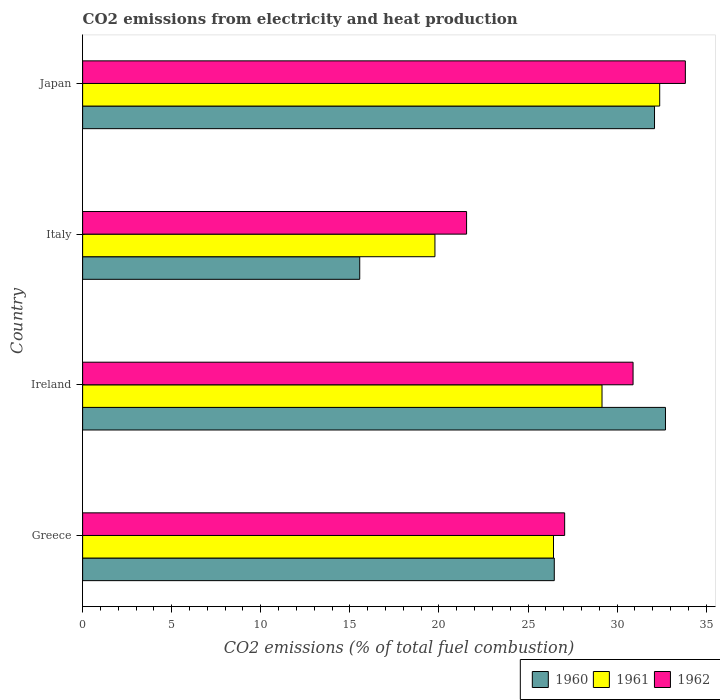How many different coloured bars are there?
Provide a succinct answer. 3. Are the number of bars per tick equal to the number of legend labels?
Ensure brevity in your answer.  Yes. Are the number of bars on each tick of the Y-axis equal?
Your answer should be very brief. Yes. What is the label of the 3rd group of bars from the top?
Offer a very short reply. Ireland. In how many cases, is the number of bars for a given country not equal to the number of legend labels?
Make the answer very short. 0. What is the amount of CO2 emitted in 1961 in Ireland?
Offer a terse response. 29.15. Across all countries, what is the maximum amount of CO2 emitted in 1961?
Ensure brevity in your answer.  32.39. Across all countries, what is the minimum amount of CO2 emitted in 1962?
Make the answer very short. 21.55. In which country was the amount of CO2 emitted in 1962 maximum?
Provide a succinct answer. Japan. In which country was the amount of CO2 emitted in 1960 minimum?
Provide a succinct answer. Italy. What is the total amount of CO2 emitted in 1962 in the graph?
Your response must be concise. 113.34. What is the difference between the amount of CO2 emitted in 1960 in Greece and that in Japan?
Offer a terse response. -5.63. What is the difference between the amount of CO2 emitted in 1961 in Italy and the amount of CO2 emitted in 1960 in Japan?
Ensure brevity in your answer.  -12.33. What is the average amount of CO2 emitted in 1960 per country?
Your answer should be very brief. 26.71. What is the difference between the amount of CO2 emitted in 1962 and amount of CO2 emitted in 1961 in Ireland?
Your response must be concise. 1.74. In how many countries, is the amount of CO2 emitted in 1962 greater than 24 %?
Make the answer very short. 3. What is the ratio of the amount of CO2 emitted in 1962 in Italy to that in Japan?
Your response must be concise. 0.64. Is the amount of CO2 emitted in 1960 in Greece less than that in Italy?
Your response must be concise. No. Is the difference between the amount of CO2 emitted in 1962 in Ireland and Japan greater than the difference between the amount of CO2 emitted in 1961 in Ireland and Japan?
Your response must be concise. Yes. What is the difference between the highest and the second highest amount of CO2 emitted in 1962?
Your answer should be very brief. 2.94. What is the difference between the highest and the lowest amount of CO2 emitted in 1962?
Your answer should be compact. 12.28. Is the sum of the amount of CO2 emitted in 1961 in Greece and Japan greater than the maximum amount of CO2 emitted in 1960 across all countries?
Give a very brief answer. Yes. What does the 1st bar from the top in Italy represents?
Provide a succinct answer. 1962. What does the 1st bar from the bottom in Japan represents?
Ensure brevity in your answer.  1960. Is it the case that in every country, the sum of the amount of CO2 emitted in 1962 and amount of CO2 emitted in 1960 is greater than the amount of CO2 emitted in 1961?
Give a very brief answer. Yes. How many bars are there?
Make the answer very short. 12. Are the values on the major ticks of X-axis written in scientific E-notation?
Provide a succinct answer. No. How many legend labels are there?
Your response must be concise. 3. What is the title of the graph?
Provide a short and direct response. CO2 emissions from electricity and heat production. Does "1964" appear as one of the legend labels in the graph?
Offer a terse response. No. What is the label or title of the X-axis?
Provide a succinct answer. CO2 emissions (% of total fuel combustion). What is the CO2 emissions (% of total fuel combustion) in 1960 in Greece?
Your answer should be very brief. 26.47. What is the CO2 emissions (% of total fuel combustion) in 1961 in Greece?
Your response must be concise. 26.43. What is the CO2 emissions (% of total fuel combustion) in 1962 in Greece?
Make the answer very short. 27.06. What is the CO2 emissions (% of total fuel combustion) of 1960 in Ireland?
Ensure brevity in your answer.  32.72. What is the CO2 emissions (% of total fuel combustion) in 1961 in Ireland?
Keep it short and to the point. 29.15. What is the CO2 emissions (% of total fuel combustion) of 1962 in Ireland?
Your answer should be very brief. 30.9. What is the CO2 emissions (% of total fuel combustion) of 1960 in Italy?
Ensure brevity in your answer.  15.55. What is the CO2 emissions (% of total fuel combustion) in 1961 in Italy?
Your answer should be very brief. 19.78. What is the CO2 emissions (% of total fuel combustion) in 1962 in Italy?
Make the answer very short. 21.55. What is the CO2 emissions (% of total fuel combustion) in 1960 in Japan?
Make the answer very short. 32.1. What is the CO2 emissions (% of total fuel combustion) in 1961 in Japan?
Provide a succinct answer. 32.39. What is the CO2 emissions (% of total fuel combustion) of 1962 in Japan?
Your answer should be compact. 33.83. Across all countries, what is the maximum CO2 emissions (% of total fuel combustion) in 1960?
Provide a succinct answer. 32.72. Across all countries, what is the maximum CO2 emissions (% of total fuel combustion) in 1961?
Provide a short and direct response. 32.39. Across all countries, what is the maximum CO2 emissions (% of total fuel combustion) of 1962?
Offer a very short reply. 33.83. Across all countries, what is the minimum CO2 emissions (% of total fuel combustion) in 1960?
Your response must be concise. 15.55. Across all countries, what is the minimum CO2 emissions (% of total fuel combustion) in 1961?
Give a very brief answer. 19.78. Across all countries, what is the minimum CO2 emissions (% of total fuel combustion) of 1962?
Keep it short and to the point. 21.55. What is the total CO2 emissions (% of total fuel combustion) in 1960 in the graph?
Provide a short and direct response. 106.85. What is the total CO2 emissions (% of total fuel combustion) of 1961 in the graph?
Your answer should be very brief. 107.75. What is the total CO2 emissions (% of total fuel combustion) in 1962 in the graph?
Provide a short and direct response. 113.34. What is the difference between the CO2 emissions (% of total fuel combustion) of 1960 in Greece and that in Ireland?
Ensure brevity in your answer.  -6.24. What is the difference between the CO2 emissions (% of total fuel combustion) of 1961 in Greece and that in Ireland?
Your answer should be very brief. -2.72. What is the difference between the CO2 emissions (% of total fuel combustion) of 1962 in Greece and that in Ireland?
Offer a terse response. -3.84. What is the difference between the CO2 emissions (% of total fuel combustion) in 1960 in Greece and that in Italy?
Give a very brief answer. 10.92. What is the difference between the CO2 emissions (% of total fuel combustion) in 1961 in Greece and that in Italy?
Your response must be concise. 6.66. What is the difference between the CO2 emissions (% of total fuel combustion) of 1962 in Greece and that in Italy?
Provide a succinct answer. 5.51. What is the difference between the CO2 emissions (% of total fuel combustion) of 1960 in Greece and that in Japan?
Give a very brief answer. -5.63. What is the difference between the CO2 emissions (% of total fuel combustion) in 1961 in Greece and that in Japan?
Your answer should be very brief. -5.96. What is the difference between the CO2 emissions (% of total fuel combustion) in 1962 in Greece and that in Japan?
Offer a very short reply. -6.78. What is the difference between the CO2 emissions (% of total fuel combustion) in 1960 in Ireland and that in Italy?
Offer a terse response. 17.16. What is the difference between the CO2 emissions (% of total fuel combustion) of 1961 in Ireland and that in Italy?
Ensure brevity in your answer.  9.38. What is the difference between the CO2 emissions (% of total fuel combustion) of 1962 in Ireland and that in Italy?
Ensure brevity in your answer.  9.35. What is the difference between the CO2 emissions (% of total fuel combustion) of 1960 in Ireland and that in Japan?
Offer a terse response. 0.61. What is the difference between the CO2 emissions (% of total fuel combustion) in 1961 in Ireland and that in Japan?
Offer a very short reply. -3.24. What is the difference between the CO2 emissions (% of total fuel combustion) of 1962 in Ireland and that in Japan?
Offer a very short reply. -2.94. What is the difference between the CO2 emissions (% of total fuel combustion) in 1960 in Italy and that in Japan?
Provide a succinct answer. -16.55. What is the difference between the CO2 emissions (% of total fuel combustion) of 1961 in Italy and that in Japan?
Keep it short and to the point. -12.62. What is the difference between the CO2 emissions (% of total fuel combustion) in 1962 in Italy and that in Japan?
Provide a short and direct response. -12.28. What is the difference between the CO2 emissions (% of total fuel combustion) in 1960 in Greece and the CO2 emissions (% of total fuel combustion) in 1961 in Ireland?
Offer a very short reply. -2.68. What is the difference between the CO2 emissions (% of total fuel combustion) of 1960 in Greece and the CO2 emissions (% of total fuel combustion) of 1962 in Ireland?
Your response must be concise. -4.42. What is the difference between the CO2 emissions (% of total fuel combustion) in 1961 in Greece and the CO2 emissions (% of total fuel combustion) in 1962 in Ireland?
Your answer should be compact. -4.47. What is the difference between the CO2 emissions (% of total fuel combustion) in 1960 in Greece and the CO2 emissions (% of total fuel combustion) in 1961 in Italy?
Provide a short and direct response. 6.7. What is the difference between the CO2 emissions (% of total fuel combustion) in 1960 in Greece and the CO2 emissions (% of total fuel combustion) in 1962 in Italy?
Your answer should be very brief. 4.92. What is the difference between the CO2 emissions (% of total fuel combustion) of 1961 in Greece and the CO2 emissions (% of total fuel combustion) of 1962 in Italy?
Keep it short and to the point. 4.88. What is the difference between the CO2 emissions (% of total fuel combustion) of 1960 in Greece and the CO2 emissions (% of total fuel combustion) of 1961 in Japan?
Give a very brief answer. -5.92. What is the difference between the CO2 emissions (% of total fuel combustion) in 1960 in Greece and the CO2 emissions (% of total fuel combustion) in 1962 in Japan?
Provide a succinct answer. -7.36. What is the difference between the CO2 emissions (% of total fuel combustion) in 1961 in Greece and the CO2 emissions (% of total fuel combustion) in 1962 in Japan?
Provide a succinct answer. -7.4. What is the difference between the CO2 emissions (% of total fuel combustion) in 1960 in Ireland and the CO2 emissions (% of total fuel combustion) in 1961 in Italy?
Provide a short and direct response. 12.94. What is the difference between the CO2 emissions (% of total fuel combustion) in 1960 in Ireland and the CO2 emissions (% of total fuel combustion) in 1962 in Italy?
Offer a very short reply. 11.16. What is the difference between the CO2 emissions (% of total fuel combustion) of 1961 in Ireland and the CO2 emissions (% of total fuel combustion) of 1962 in Italy?
Offer a very short reply. 7.6. What is the difference between the CO2 emissions (% of total fuel combustion) of 1960 in Ireland and the CO2 emissions (% of total fuel combustion) of 1961 in Japan?
Ensure brevity in your answer.  0.32. What is the difference between the CO2 emissions (% of total fuel combustion) of 1960 in Ireland and the CO2 emissions (% of total fuel combustion) of 1962 in Japan?
Your response must be concise. -1.12. What is the difference between the CO2 emissions (% of total fuel combustion) of 1961 in Ireland and the CO2 emissions (% of total fuel combustion) of 1962 in Japan?
Your answer should be compact. -4.68. What is the difference between the CO2 emissions (% of total fuel combustion) in 1960 in Italy and the CO2 emissions (% of total fuel combustion) in 1961 in Japan?
Offer a very short reply. -16.84. What is the difference between the CO2 emissions (% of total fuel combustion) of 1960 in Italy and the CO2 emissions (% of total fuel combustion) of 1962 in Japan?
Your response must be concise. -18.28. What is the difference between the CO2 emissions (% of total fuel combustion) of 1961 in Italy and the CO2 emissions (% of total fuel combustion) of 1962 in Japan?
Give a very brief answer. -14.06. What is the average CO2 emissions (% of total fuel combustion) of 1960 per country?
Keep it short and to the point. 26.71. What is the average CO2 emissions (% of total fuel combustion) of 1961 per country?
Your answer should be compact. 26.94. What is the average CO2 emissions (% of total fuel combustion) of 1962 per country?
Ensure brevity in your answer.  28.33. What is the difference between the CO2 emissions (% of total fuel combustion) in 1960 and CO2 emissions (% of total fuel combustion) in 1961 in Greece?
Offer a terse response. 0.04. What is the difference between the CO2 emissions (% of total fuel combustion) in 1960 and CO2 emissions (% of total fuel combustion) in 1962 in Greece?
Keep it short and to the point. -0.58. What is the difference between the CO2 emissions (% of total fuel combustion) in 1961 and CO2 emissions (% of total fuel combustion) in 1962 in Greece?
Offer a very short reply. -0.63. What is the difference between the CO2 emissions (% of total fuel combustion) in 1960 and CO2 emissions (% of total fuel combustion) in 1961 in Ireland?
Provide a short and direct response. 3.56. What is the difference between the CO2 emissions (% of total fuel combustion) in 1960 and CO2 emissions (% of total fuel combustion) in 1962 in Ireland?
Keep it short and to the point. 1.82. What is the difference between the CO2 emissions (% of total fuel combustion) of 1961 and CO2 emissions (% of total fuel combustion) of 1962 in Ireland?
Provide a short and direct response. -1.74. What is the difference between the CO2 emissions (% of total fuel combustion) in 1960 and CO2 emissions (% of total fuel combustion) in 1961 in Italy?
Ensure brevity in your answer.  -4.22. What is the difference between the CO2 emissions (% of total fuel combustion) in 1960 and CO2 emissions (% of total fuel combustion) in 1962 in Italy?
Ensure brevity in your answer.  -6. What is the difference between the CO2 emissions (% of total fuel combustion) of 1961 and CO2 emissions (% of total fuel combustion) of 1962 in Italy?
Provide a short and direct response. -1.78. What is the difference between the CO2 emissions (% of total fuel combustion) in 1960 and CO2 emissions (% of total fuel combustion) in 1961 in Japan?
Keep it short and to the point. -0.29. What is the difference between the CO2 emissions (% of total fuel combustion) in 1960 and CO2 emissions (% of total fuel combustion) in 1962 in Japan?
Your response must be concise. -1.73. What is the difference between the CO2 emissions (% of total fuel combustion) in 1961 and CO2 emissions (% of total fuel combustion) in 1962 in Japan?
Provide a short and direct response. -1.44. What is the ratio of the CO2 emissions (% of total fuel combustion) in 1960 in Greece to that in Ireland?
Keep it short and to the point. 0.81. What is the ratio of the CO2 emissions (% of total fuel combustion) in 1961 in Greece to that in Ireland?
Your answer should be very brief. 0.91. What is the ratio of the CO2 emissions (% of total fuel combustion) of 1962 in Greece to that in Ireland?
Keep it short and to the point. 0.88. What is the ratio of the CO2 emissions (% of total fuel combustion) of 1960 in Greece to that in Italy?
Your response must be concise. 1.7. What is the ratio of the CO2 emissions (% of total fuel combustion) in 1961 in Greece to that in Italy?
Offer a terse response. 1.34. What is the ratio of the CO2 emissions (% of total fuel combustion) in 1962 in Greece to that in Italy?
Your response must be concise. 1.26. What is the ratio of the CO2 emissions (% of total fuel combustion) in 1960 in Greece to that in Japan?
Keep it short and to the point. 0.82. What is the ratio of the CO2 emissions (% of total fuel combustion) in 1961 in Greece to that in Japan?
Offer a terse response. 0.82. What is the ratio of the CO2 emissions (% of total fuel combustion) in 1962 in Greece to that in Japan?
Make the answer very short. 0.8. What is the ratio of the CO2 emissions (% of total fuel combustion) of 1960 in Ireland to that in Italy?
Your response must be concise. 2.1. What is the ratio of the CO2 emissions (% of total fuel combustion) of 1961 in Ireland to that in Italy?
Ensure brevity in your answer.  1.47. What is the ratio of the CO2 emissions (% of total fuel combustion) in 1962 in Ireland to that in Italy?
Provide a short and direct response. 1.43. What is the ratio of the CO2 emissions (% of total fuel combustion) of 1960 in Ireland to that in Japan?
Keep it short and to the point. 1.02. What is the ratio of the CO2 emissions (% of total fuel combustion) in 1961 in Ireland to that in Japan?
Give a very brief answer. 0.9. What is the ratio of the CO2 emissions (% of total fuel combustion) of 1962 in Ireland to that in Japan?
Keep it short and to the point. 0.91. What is the ratio of the CO2 emissions (% of total fuel combustion) in 1960 in Italy to that in Japan?
Offer a terse response. 0.48. What is the ratio of the CO2 emissions (% of total fuel combustion) of 1961 in Italy to that in Japan?
Make the answer very short. 0.61. What is the ratio of the CO2 emissions (% of total fuel combustion) in 1962 in Italy to that in Japan?
Provide a short and direct response. 0.64. What is the difference between the highest and the second highest CO2 emissions (% of total fuel combustion) in 1960?
Your response must be concise. 0.61. What is the difference between the highest and the second highest CO2 emissions (% of total fuel combustion) of 1961?
Your answer should be compact. 3.24. What is the difference between the highest and the second highest CO2 emissions (% of total fuel combustion) of 1962?
Offer a very short reply. 2.94. What is the difference between the highest and the lowest CO2 emissions (% of total fuel combustion) in 1960?
Give a very brief answer. 17.16. What is the difference between the highest and the lowest CO2 emissions (% of total fuel combustion) of 1961?
Your response must be concise. 12.62. What is the difference between the highest and the lowest CO2 emissions (% of total fuel combustion) in 1962?
Your answer should be very brief. 12.28. 